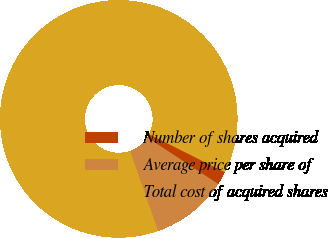<chart> <loc_0><loc_0><loc_500><loc_500><pie_chart><fcel>Number of shares acquired<fcel>Average price per share of<fcel>Total cost of acquired shares<nl><fcel>1.82%<fcel>10.41%<fcel>87.77%<nl></chart> 